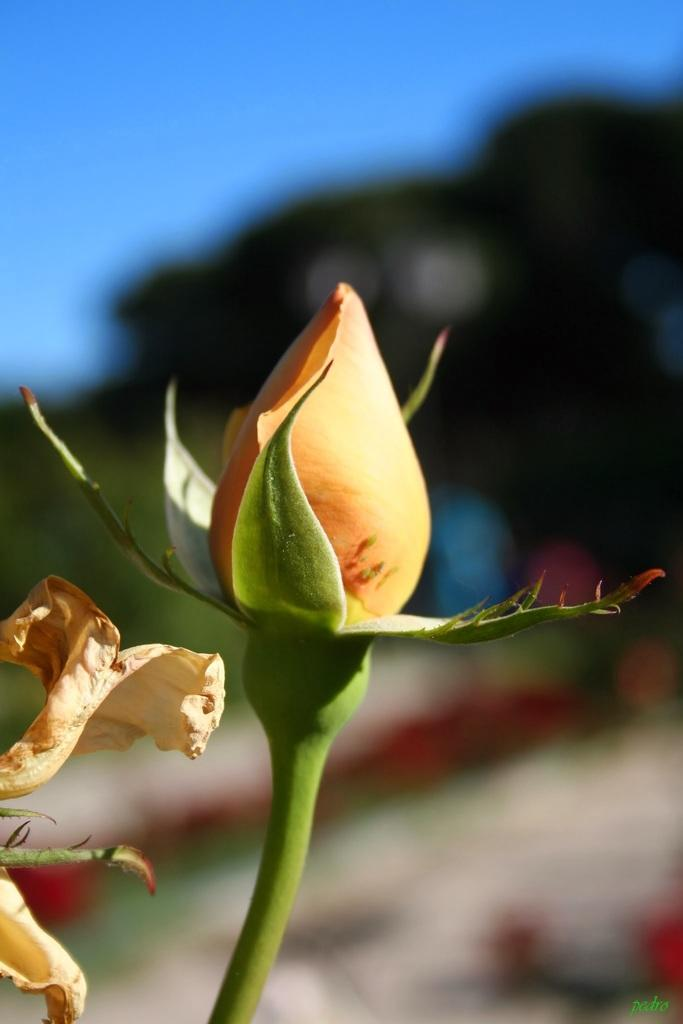What is the main subject of the image? There is a flower bud in the image. Are there any other flowers visible in the image? Yes, there is another flower on the left side of the image. What can be seen in the background of the image? There are trees in the background of the image. What is the condition of the sky in the image? The sky is clear in the image. Is there a monkey visible in the image? No, there is no monkey present in the image. Can you see any cobwebs in the image? No, there are no cobwebs visible in the image. 